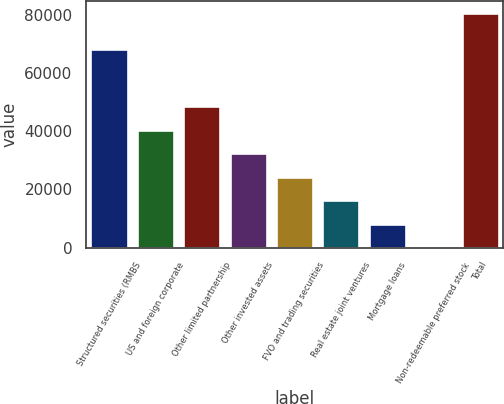<chart> <loc_0><loc_0><loc_500><loc_500><bar_chart><fcel>Structured securities (RMBS<fcel>US and foreign corporate<fcel>Other limited partnership<fcel>Other invested assets<fcel>FVO and trading securities<fcel>Real estate joint ventures<fcel>Mortgage loans<fcel>Non-redeemable preferred stock<fcel>Total<nl><fcel>68427<fcel>40512<fcel>48606.2<fcel>32417.8<fcel>24323.6<fcel>16229.4<fcel>8135.2<fcel>41<fcel>80983<nl></chart> 